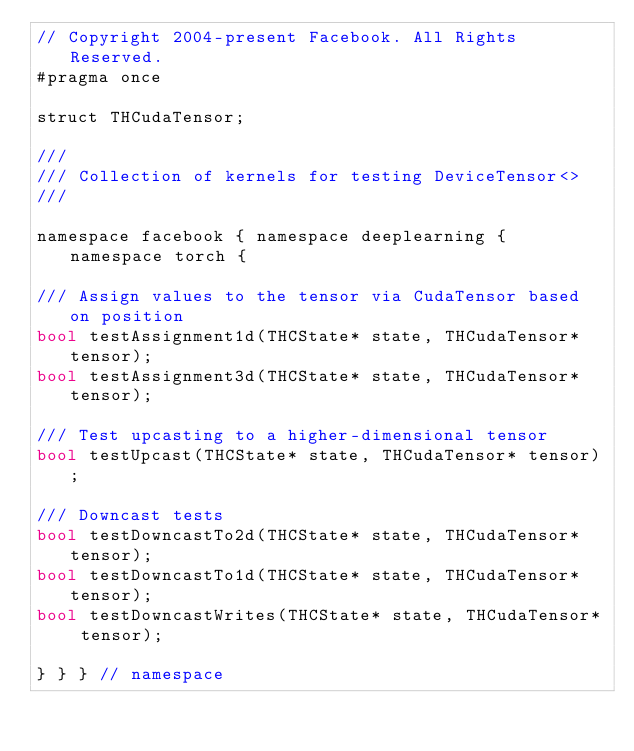Convert code to text. <code><loc_0><loc_0><loc_500><loc_500><_Cuda_>// Copyright 2004-present Facebook. All Rights Reserved.
#pragma once

struct THCudaTensor;

///
/// Collection of kernels for testing DeviceTensor<>
///

namespace facebook { namespace deeplearning { namespace torch {

/// Assign values to the tensor via CudaTensor based on position
bool testAssignment1d(THCState* state, THCudaTensor* tensor);
bool testAssignment3d(THCState* state, THCudaTensor* tensor);

/// Test upcasting to a higher-dimensional tensor
bool testUpcast(THCState* state, THCudaTensor* tensor);

/// Downcast tests
bool testDowncastTo2d(THCState* state, THCudaTensor* tensor);
bool testDowncastTo1d(THCState* state, THCudaTensor* tensor);
bool testDowncastWrites(THCState* state, THCudaTensor* tensor);

} } } // namespace
</code> 